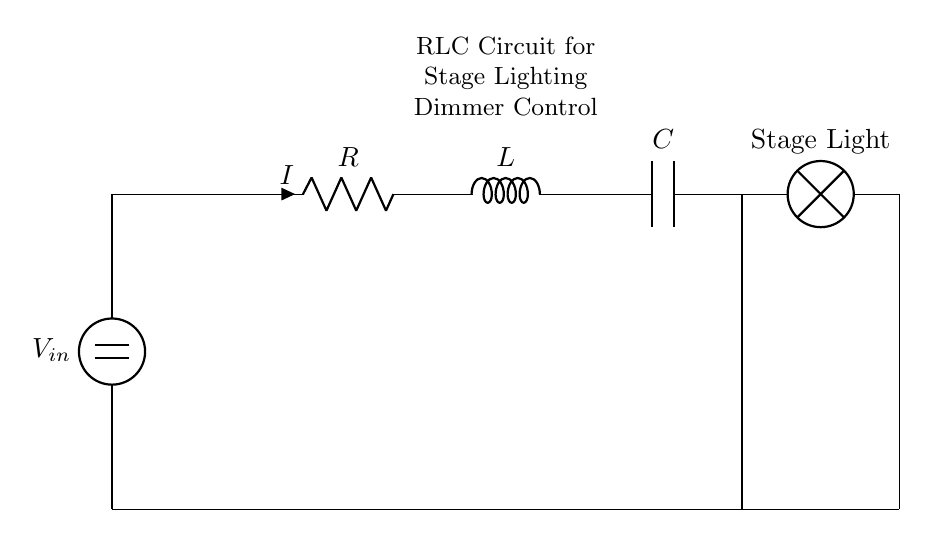What are the components in this circuit? The circuit diagram shows three main components: a resistor (R), an inductor (L), and a capacitor (C). These elements are connected in series and crucial for controlling the light dimming in stage lighting.
Answer: Resistor, Inductor, Capacitor What is the purpose of the inductor in this circuit? The inductor primarily stores energy in a magnetic field when current passes through it. In the context of a dimmer, it helps manage the phase and smoothens the current flow to the lamp, contributing to light control.
Answer: Energy storage What is the function of the capacitor in this circuit? The capacitor serves to store electric charge and can release it when needed. In this circuit, it helps filter and smooth out fluctuations in voltage, ensuring a steady light output.
Answer: Voltage smoothing What is the voltage source in this circuit? The voltage source is labeled as V in the diagram, representing the input voltage that powers the circuit and drives current through the components.
Answer: V Why is the resistor placed before the inductor in this circuit? The placement of the resistor before the inductor allows for initial resistance to current flow. This design helps control the overall current passing through the circuit, leading to better dimming control of the stage lights.
Answer: To control current Is this circuit an example of a series or parallel connection? This circuit is a series connection, as all components (R, L, and C) are aligned in a single path for the current to flow through, which is typical for RLC circuits in dimming applications.
Answer: Series connection 